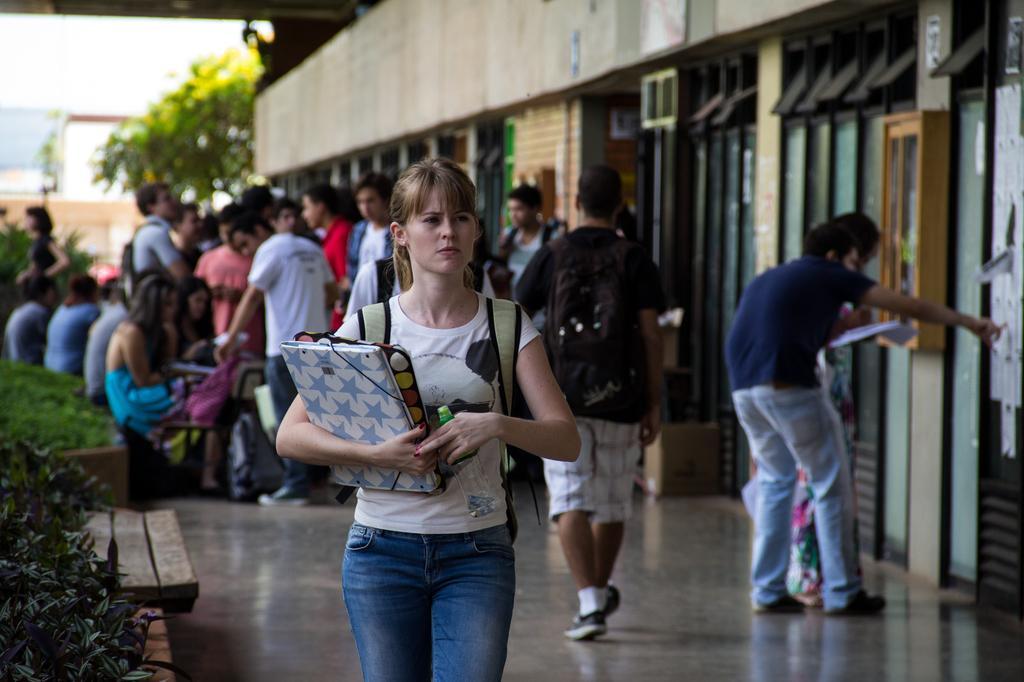Please provide a concise description of this image. In the picture I can see a woman wearing white color T-shirt and holding some objects is carrying a backpack and is at the center of the image. The background of the image is blurred, where we can see a few more people, we can see shrubs on the left side of the image, on the right side, we can see the boards and the buildings and the trees and sky in the background. 